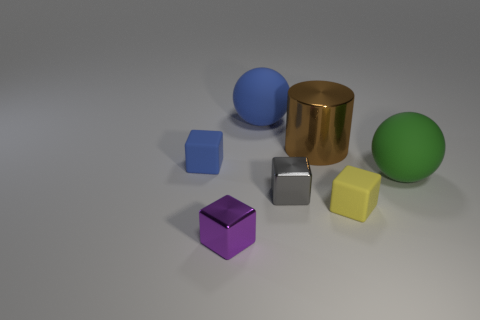There is a small rubber thing left of the blue sphere; are there any big green matte objects that are to the left of it?
Give a very brief answer. No. How many other objects are there of the same shape as the gray thing?
Make the answer very short. 3. Are there more tiny things that are to the right of the purple shiny cube than gray metal things in front of the tiny gray thing?
Your response must be concise. Yes. Do the sphere that is behind the large green rubber sphere and the gray block that is right of the big blue object have the same size?
Keep it short and to the point. No. What is the shape of the yellow rubber object?
Keep it short and to the point. Cube. What color is the large object that is the same material as the big blue ball?
Provide a short and direct response. Green. Does the brown cylinder have the same material as the sphere that is to the right of the gray thing?
Your answer should be very brief. No. The big metal thing has what color?
Your answer should be compact. Brown. What is the size of the block that is the same material as the tiny gray object?
Give a very brief answer. Small. How many large blue objects are to the left of the small matte cube on the left side of the large matte object left of the small gray shiny object?
Your answer should be compact. 0. 